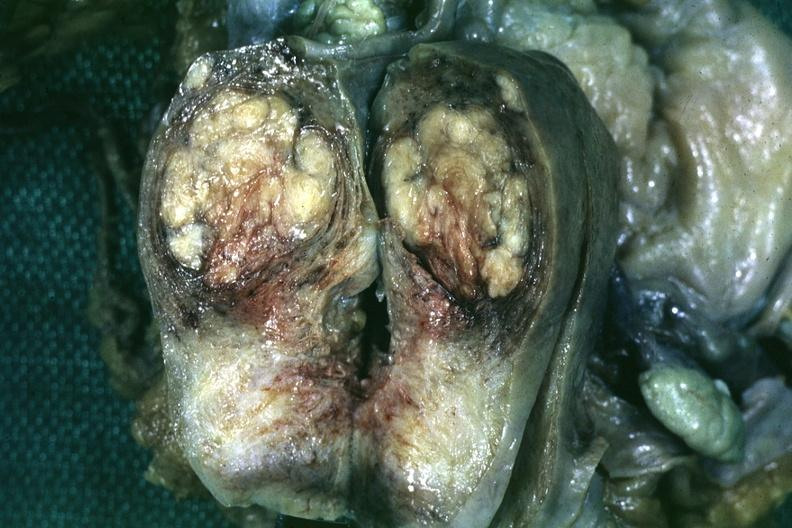s uterus present?
Answer the question using a single word or phrase. Yes 